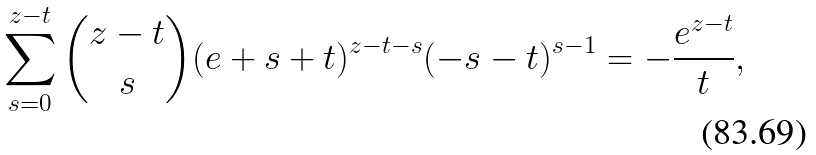Convert formula to latex. <formula><loc_0><loc_0><loc_500><loc_500>\sum _ { s = 0 } ^ { z - t } \binom { z - t } { s } ( e + s + t ) ^ { z - t - s } ( - s - t ) ^ { s - 1 } = - \frac { e ^ { z - t } } { t } ,</formula> 